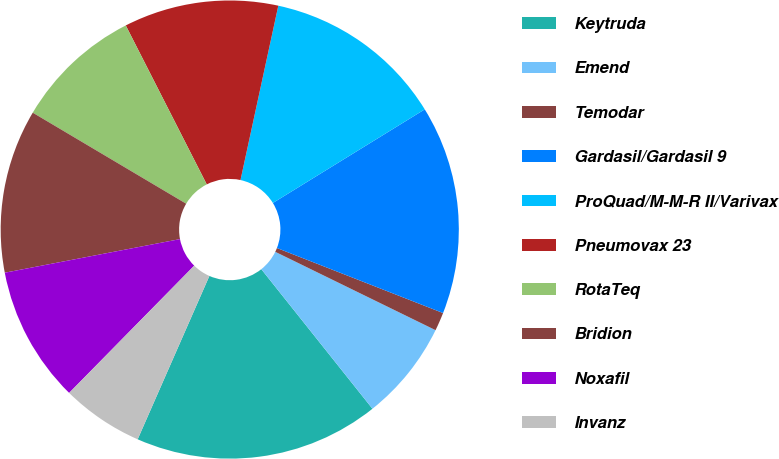<chart> <loc_0><loc_0><loc_500><loc_500><pie_chart><fcel>Keytruda<fcel>Emend<fcel>Temodar<fcel>Gardasil/Gardasil 9<fcel>ProQuad/M-M-R II/Varivax<fcel>Pneumovax 23<fcel>RotaTeq<fcel>Bridion<fcel>Noxafil<fcel>Invanz<nl><fcel>17.29%<fcel>7.06%<fcel>1.3%<fcel>14.73%<fcel>12.81%<fcel>10.9%<fcel>8.98%<fcel>11.54%<fcel>9.62%<fcel>5.78%<nl></chart> 